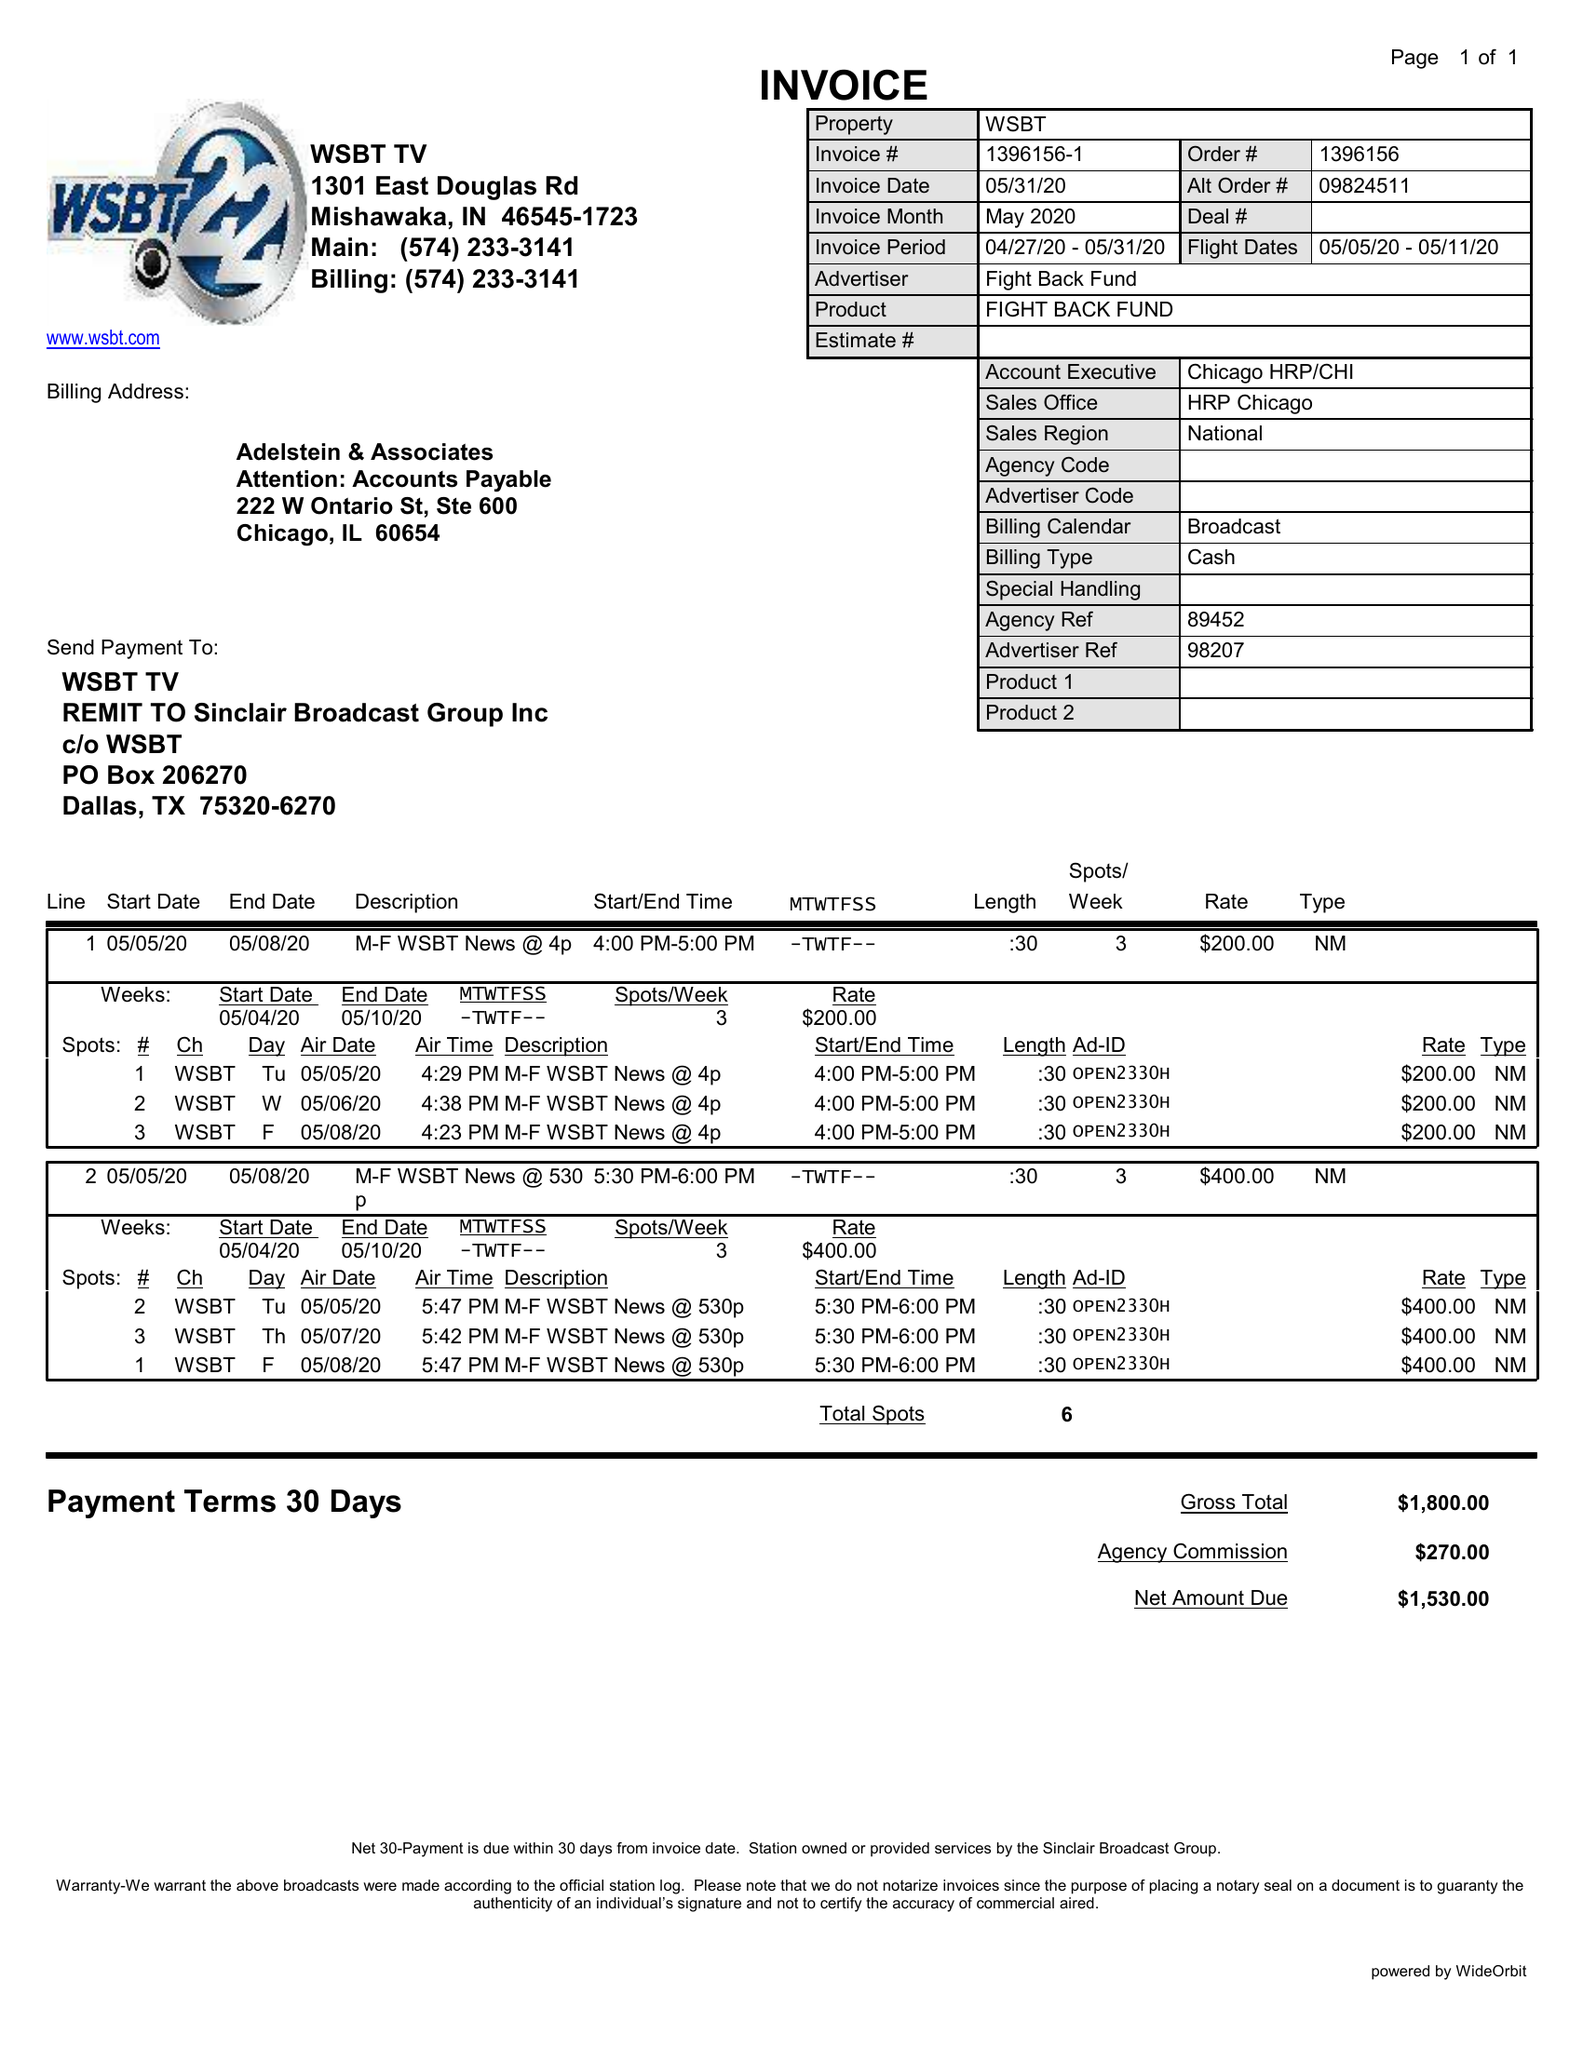What is the value for the flight_from?
Answer the question using a single word or phrase. 05/05/20 